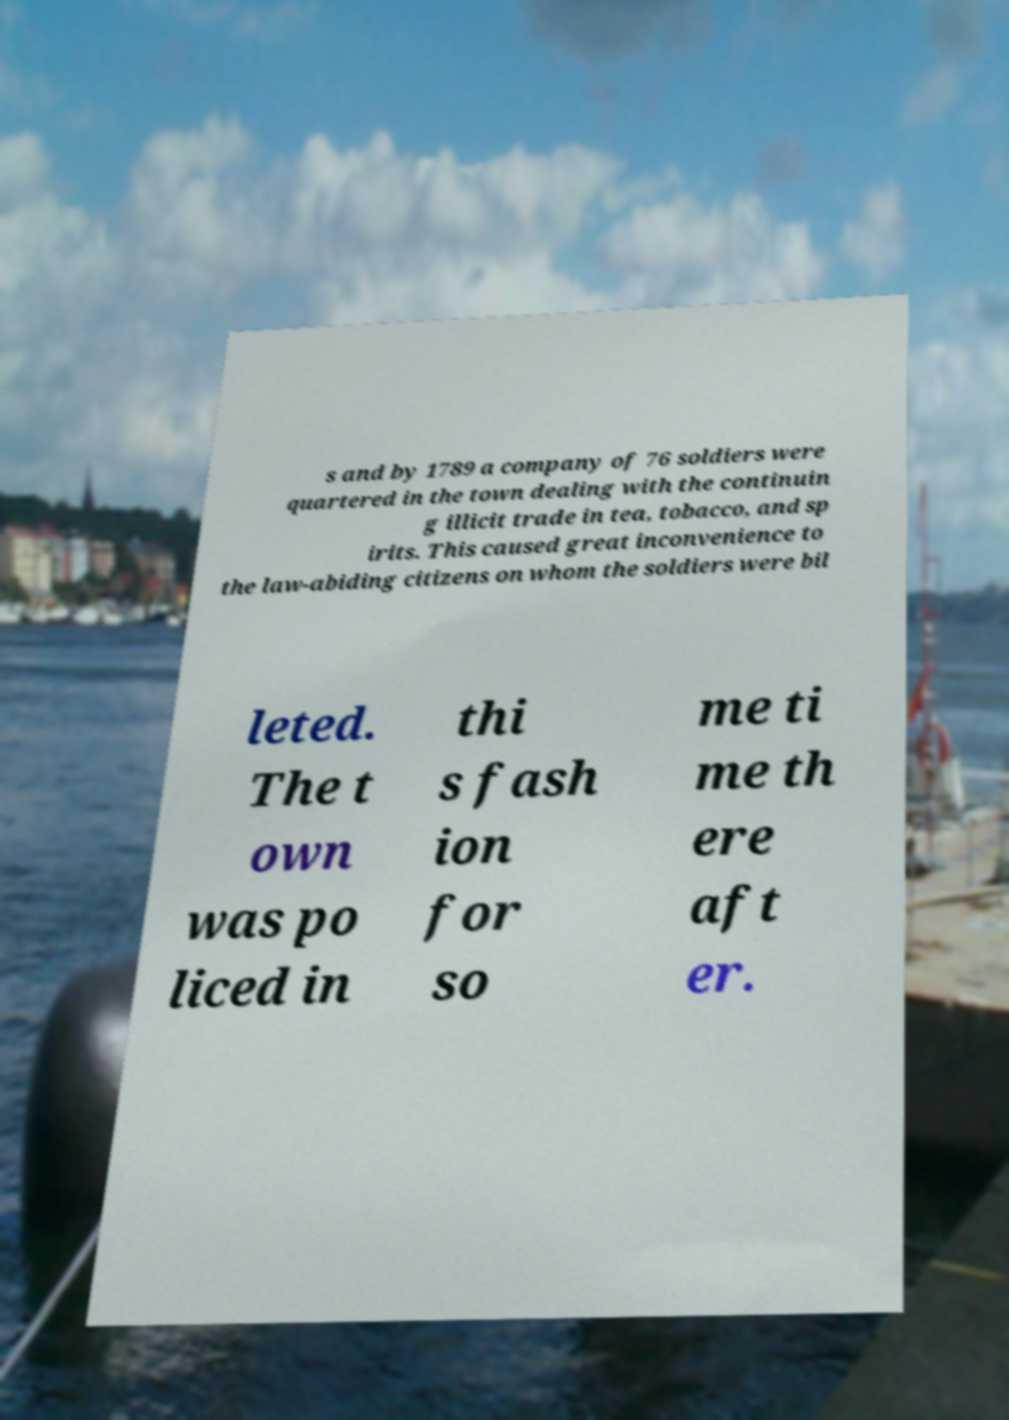I need the written content from this picture converted into text. Can you do that? s and by 1789 a company of 76 soldiers were quartered in the town dealing with the continuin g illicit trade in tea, tobacco, and sp irits. This caused great inconvenience to the law-abiding citizens on whom the soldiers were bil leted. The t own was po liced in thi s fash ion for so me ti me th ere aft er. 